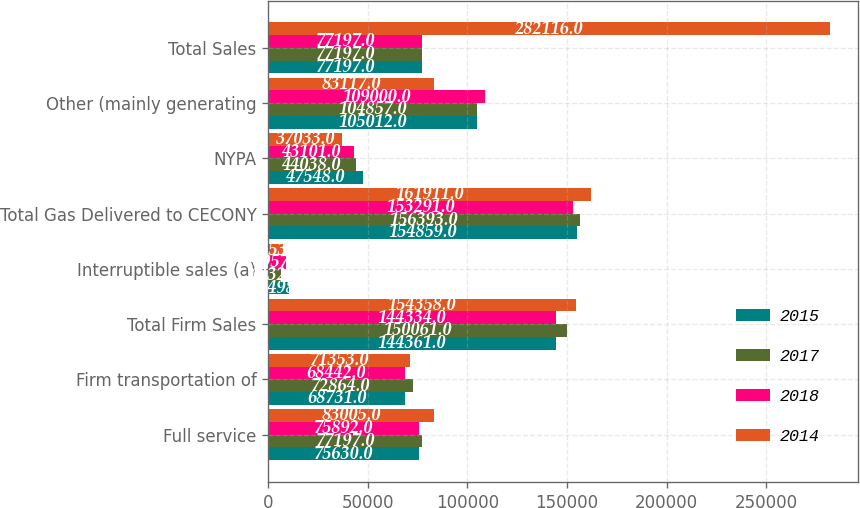Convert chart to OTSL. <chart><loc_0><loc_0><loc_500><loc_500><stacked_bar_chart><ecel><fcel>Full service<fcel>Firm transportation of<fcel>Total Firm Sales<fcel>Interruptible sales (a)<fcel>Total Gas Delivered to CECONY<fcel>NYPA<fcel>Other (mainly generating<fcel>Total Sales<nl><fcel>2015<fcel>75630<fcel>68731<fcel>144361<fcel>10498<fcel>154859<fcel>47548<fcel>105012<fcel>77197<nl><fcel>2017<fcel>77197<fcel>72864<fcel>150061<fcel>6332<fcel>156393<fcel>44038<fcel>104857<fcel>77197<nl><fcel>2018<fcel>75892<fcel>68442<fcel>144334<fcel>8957<fcel>153291<fcel>43101<fcel>109000<fcel>77197<nl><fcel>2014<fcel>83005<fcel>71353<fcel>154358<fcel>7553<fcel>161911<fcel>37033<fcel>83117<fcel>282116<nl></chart> 